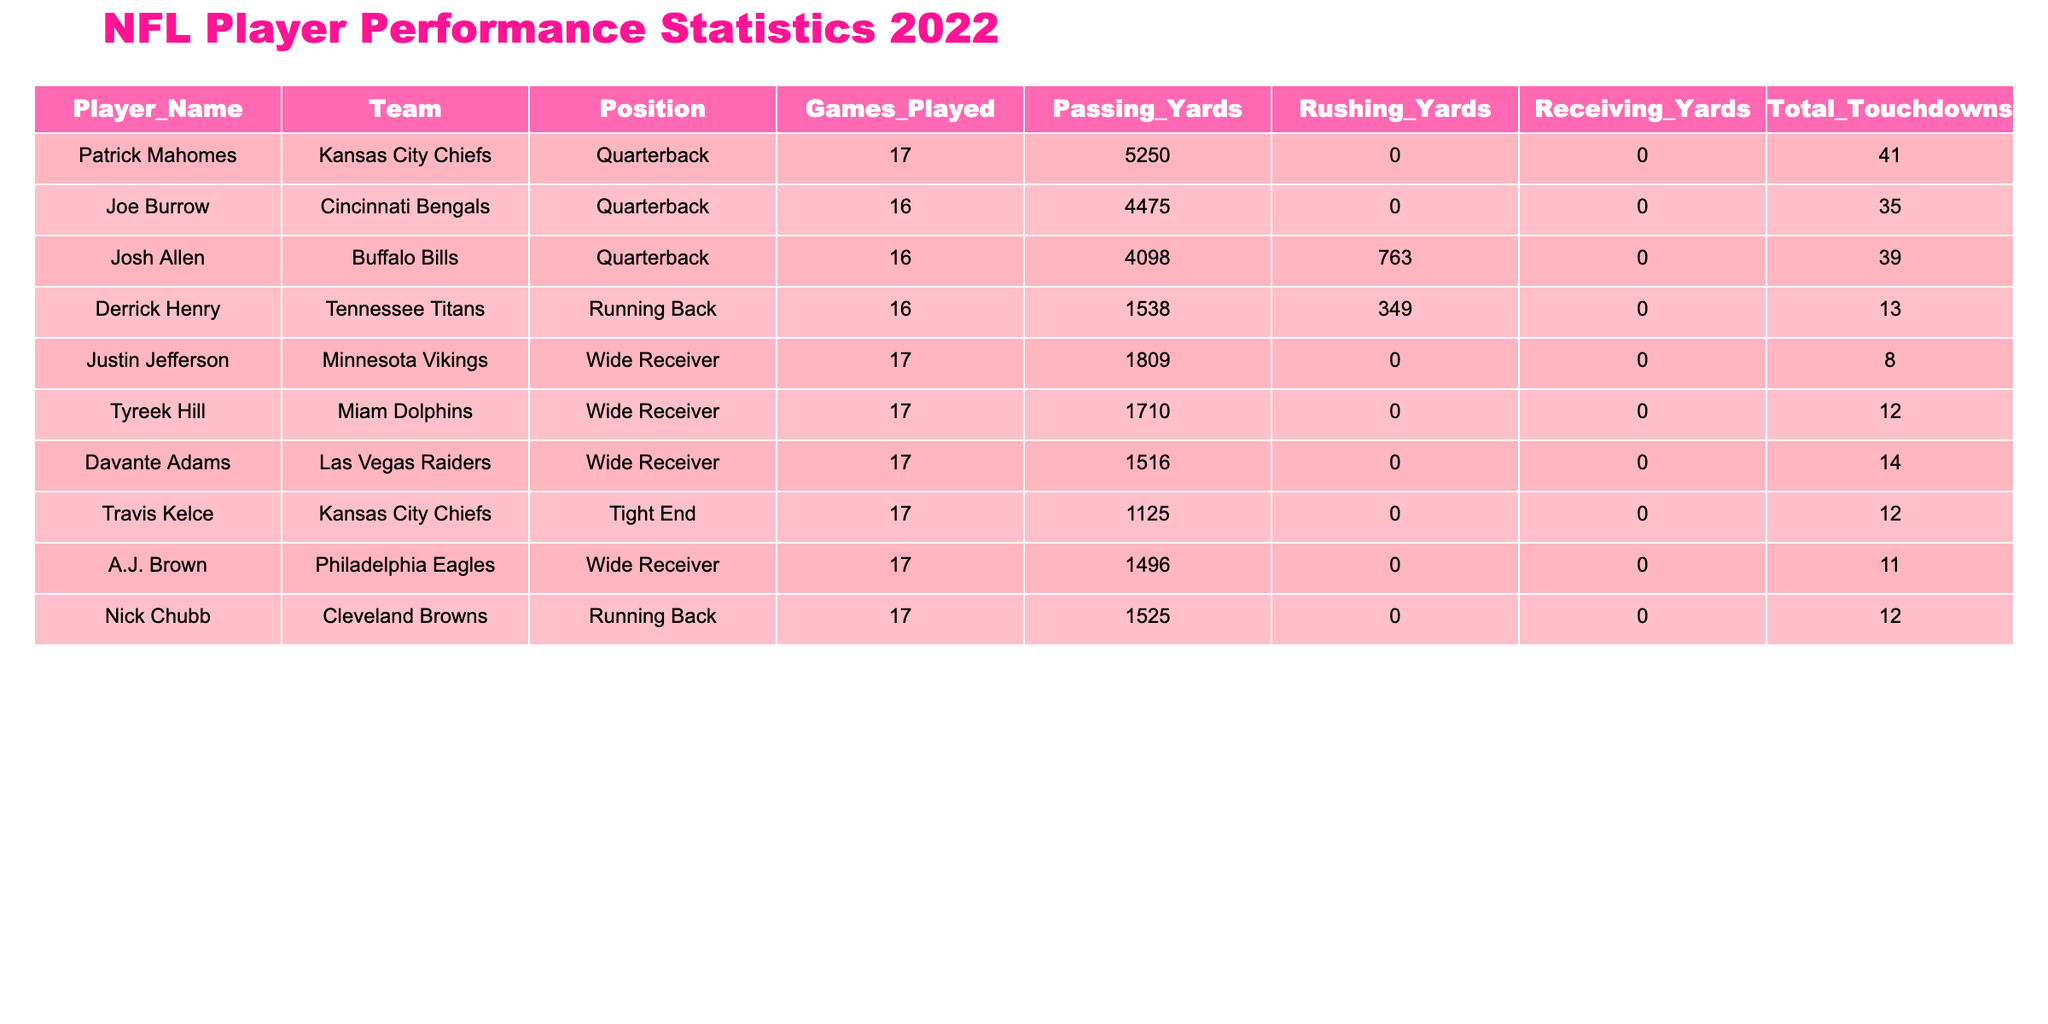What team does Patrick Mahomes play for? According to the table, Patrick Mahomes is listed under the Team column for the Kansas City Chiefs.
Answer: Kansas City Chiefs Which player scored the most total touchdowns in the 2022 NFL season? By looking at the Total Touchdowns column, the highest value is 41 by Patrick Mahomes.
Answer: Patrick Mahomes How many passing yards did Joe Burrow achieve? The Passing Yards column shows that Joe Burrow achieved 4475 passing yards during the season.
Answer: 4475 What is the total number of touchdowns scored by running backs in the table? Adding the Total Touchdowns for Derrick Henry (13) and Nick Chubb (12), gives a total of 25 touchdowns for running backs.
Answer: 25 Did Justin Jefferson have more receiving yards than Derrick Henry had rushing yards? The table indicates Justin Jefferson had 0 receiving yards, while Derrick Henry had 349 rushing yards. Therefore, the answer is no, he did not.
Answer: No Which player had the highest rushing yards? The highest rushing yards in the Rushing Yards column is 763 by Josh Allen, indicating he had the most amongst the players listed.
Answer: 763 What are the average total touchdowns scored by the wide receivers in this table? The available wide receivers are Justin Jefferson (8), Tyreek Hill (12), Davante Adams (14), and A.J. Brown (11), making it (8 + 12 + 14 + 11) / 4 = 11.25 as the average.
Answer: 11.25 Which player has the lowest number of total touchdowns, and how many did they score? By examining the Total Touchdowns column, Justin Jefferson has the lowest with 8 touchdowns.
Answer: Justin Jefferson, 8 touchdowns Is it true that all players listed had more than 15 games played? The table shows that all players had a minimum of 16 games played, therefore this statement is true.
Answer: Yes 